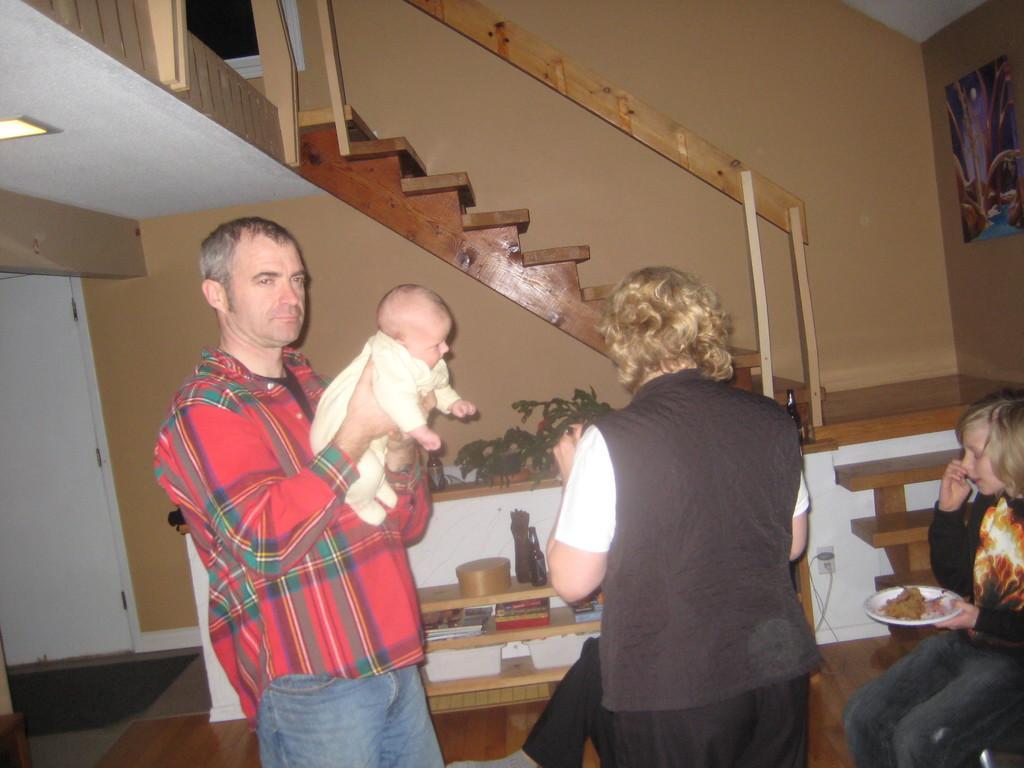Can you describe this image briefly? In this image we can see a man carrying a child and there is a woman standing beside him. On the right side we can see a person sitting on the chair holding a plate. On the backside we can see the stairs, some books in the shelves and a photo frame hanged to a wall. 